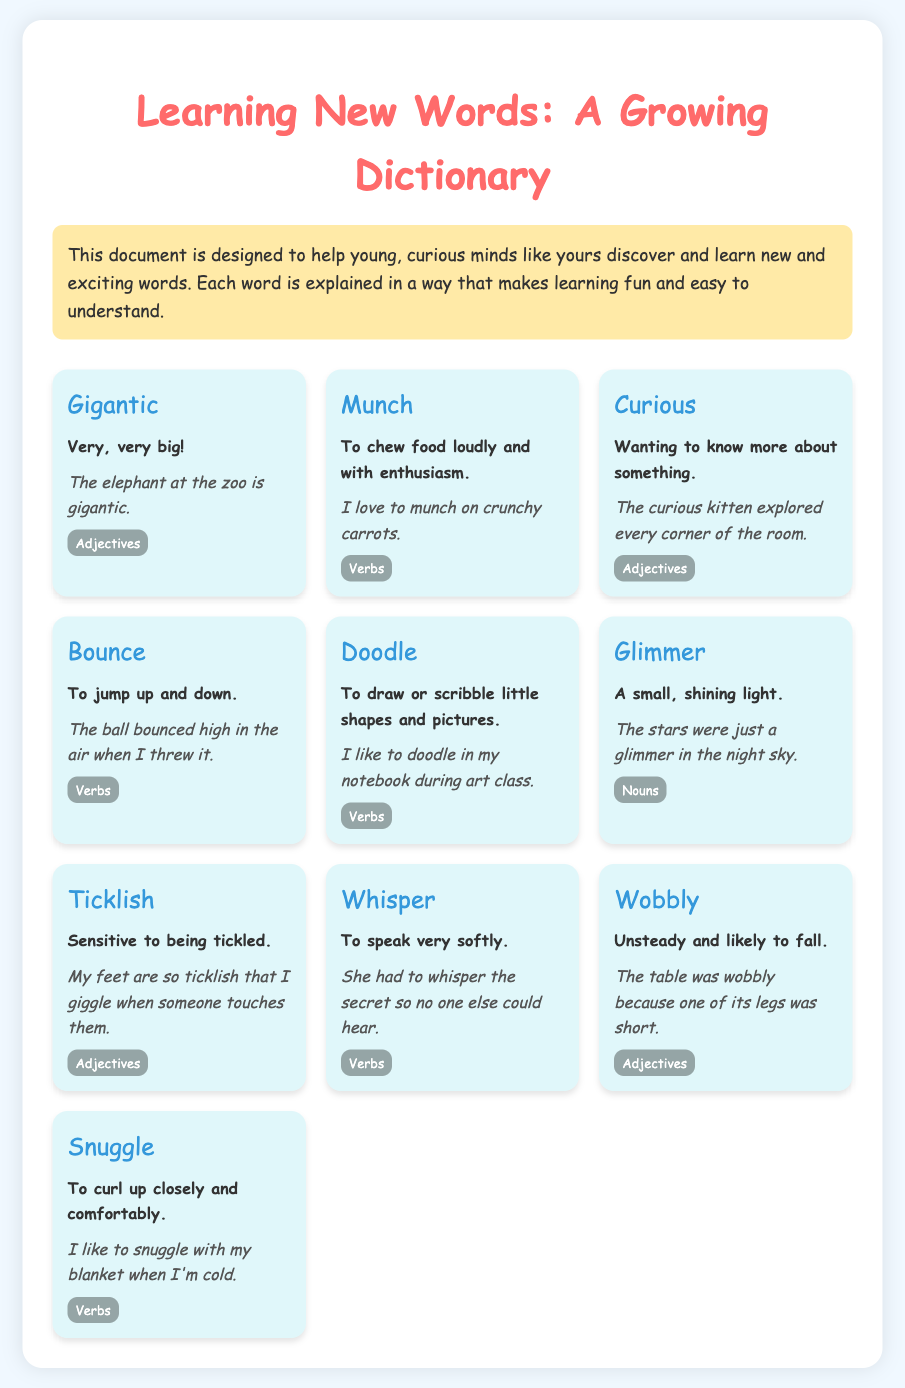What is the title of the document? The title of the document is given at the top of the page.
Answer: Learning New Words: A Growing Dictionary How many words are listed in the document? There are ten individual words presented in the word list of the document.
Answer: 10 What does "gigantic" mean? The meaning of "gigantic" is specified in the document as very, very big!
Answer: Very, very big! Which word means to jump up and down? The specific word that means to jump up and down is mentioned in the document.
Answer: Bounce What is an example of "munch"? The document provides an example that illustrates the usage of the word "munch."
Answer: I love to munch on crunchy carrots What category does the word "curious" belong to? The document classifies words into different categories to show their types.
Answer: Adjectives How is "whisper" described? The document explains how "whisper" is to speak very softly.
Answer: To speak very softly What does "wobbly" describe? The document provides a clear description of what "wobbly" indicates.
Answer: Unsteady and likely to fall Which word in the document is associated with drawing? The document includes a specific word related to drawing or scribbling.
Answer: Doodle 